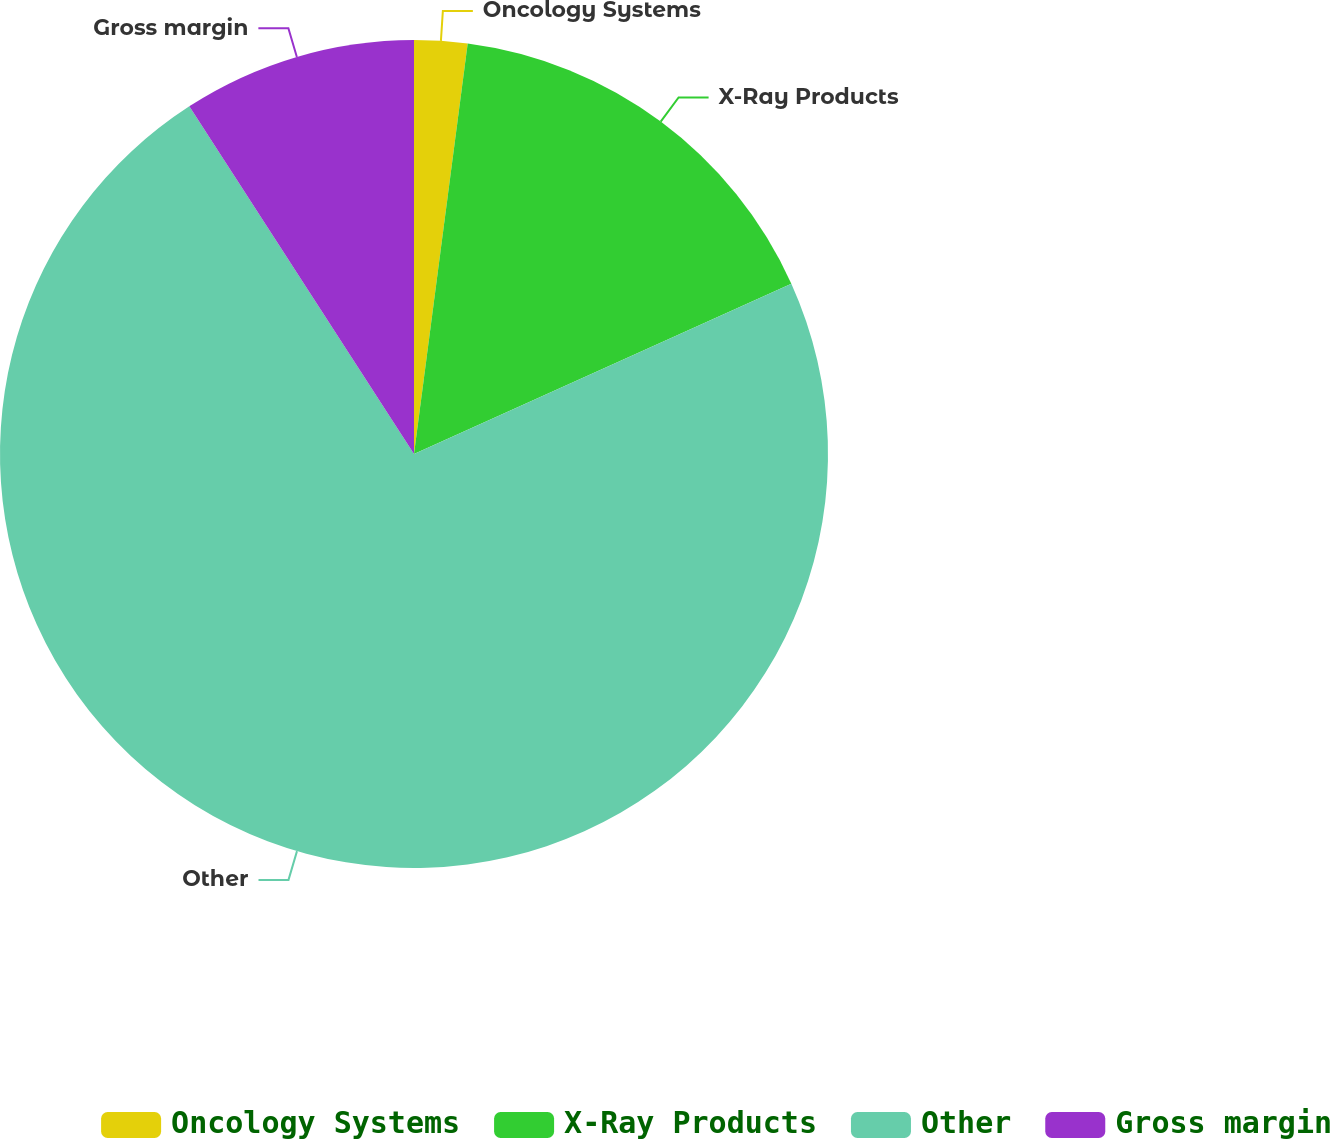<chart> <loc_0><loc_0><loc_500><loc_500><pie_chart><fcel>Oncology Systems<fcel>X-Ray Products<fcel>Other<fcel>Gross margin<nl><fcel>2.07%<fcel>16.18%<fcel>72.61%<fcel>9.13%<nl></chart> 